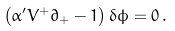<formula> <loc_0><loc_0><loc_500><loc_500>\left ( \alpha ^ { \prime } V ^ { + } \partial _ { + } - 1 \right ) \delta \phi = 0 \, .</formula> 